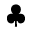<formula> <loc_0><loc_0><loc_500><loc_500>\clubsuit</formula> 